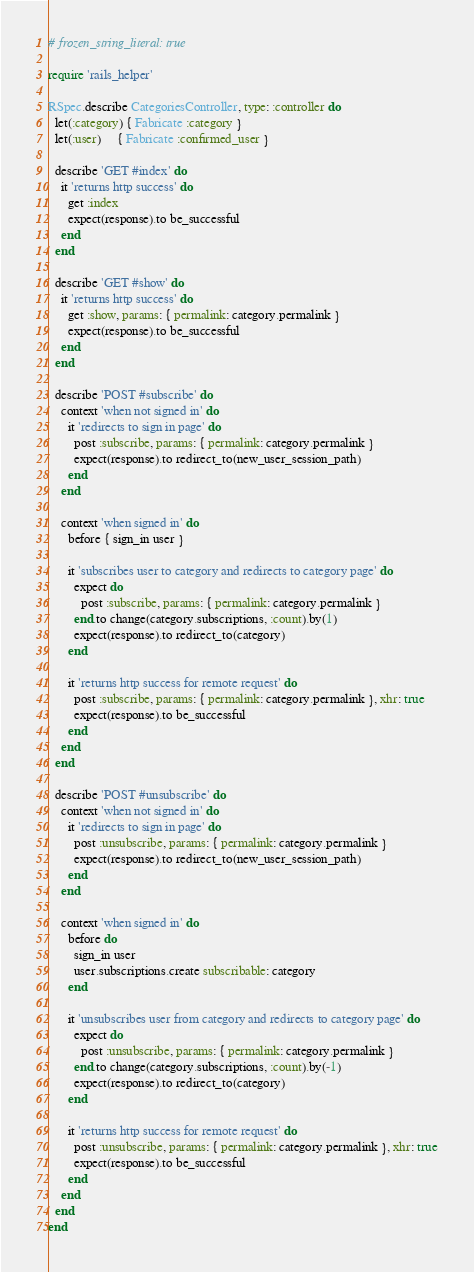Convert code to text. <code><loc_0><loc_0><loc_500><loc_500><_Ruby_># frozen_string_literal: true

require 'rails_helper'

RSpec.describe CategoriesController, type: :controller do
  let(:category) { Fabricate :category }
  let(:user)     { Fabricate :confirmed_user }

  describe 'GET #index' do
    it 'returns http success' do
      get :index
      expect(response).to be_successful
    end
  end

  describe 'GET #show' do
    it 'returns http success' do
      get :show, params: { permalink: category.permalink }
      expect(response).to be_successful
    end
  end

  describe 'POST #subscribe' do
    context 'when not signed in' do
      it 'redirects to sign in page' do
        post :subscribe, params: { permalink: category.permalink }
        expect(response).to redirect_to(new_user_session_path)
      end
    end

    context 'when signed in' do
      before { sign_in user }

      it 'subscribes user to category and redirects to category page' do
        expect do
          post :subscribe, params: { permalink: category.permalink }
        end.to change(category.subscriptions, :count).by(1)
        expect(response).to redirect_to(category)
      end

      it 'returns http success for remote request' do
        post :subscribe, params: { permalink: category.permalink }, xhr: true
        expect(response).to be_successful
      end
    end
  end

  describe 'POST #unsubscribe' do
    context 'when not signed in' do
      it 'redirects to sign in page' do
        post :unsubscribe, params: { permalink: category.permalink }
        expect(response).to redirect_to(new_user_session_path)
      end
    end

    context 'when signed in' do
      before do
        sign_in user
        user.subscriptions.create subscribable: category
      end

      it 'unsubscribes user from category and redirects to category page' do
        expect do
          post :unsubscribe, params: { permalink: category.permalink }
        end.to change(category.subscriptions, :count).by(-1)
        expect(response).to redirect_to(category)
      end

      it 'returns http success for remote request' do
        post :unsubscribe, params: { permalink: category.permalink }, xhr: true
        expect(response).to be_successful
      end
    end
  end
end
</code> 